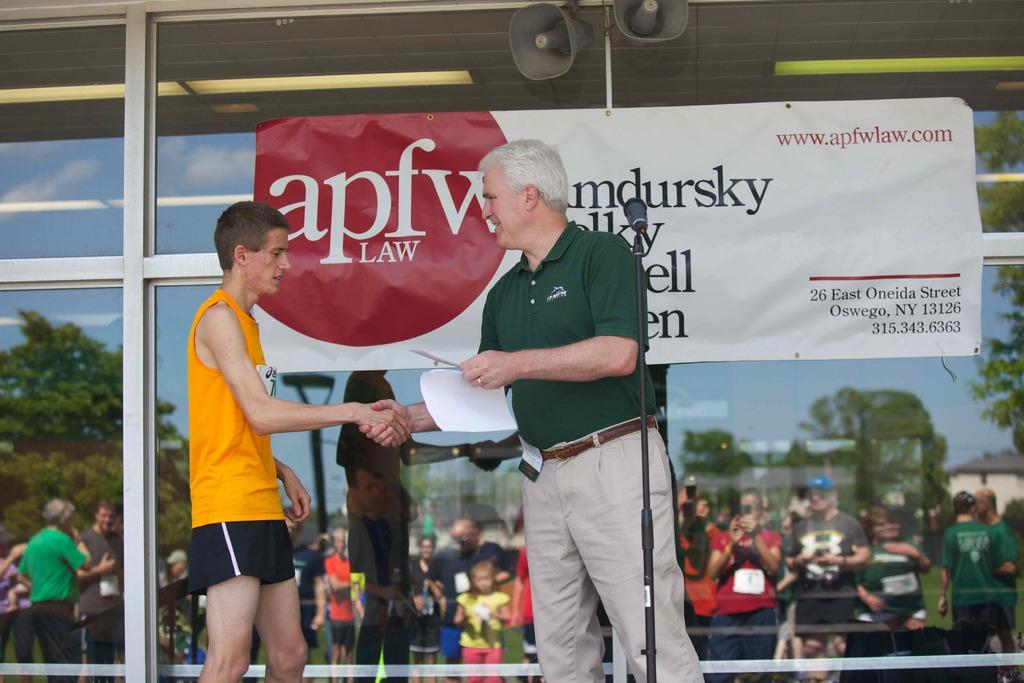Provide a one-sentence caption for the provided image. A man shakes a young male's hand at apfw law. 